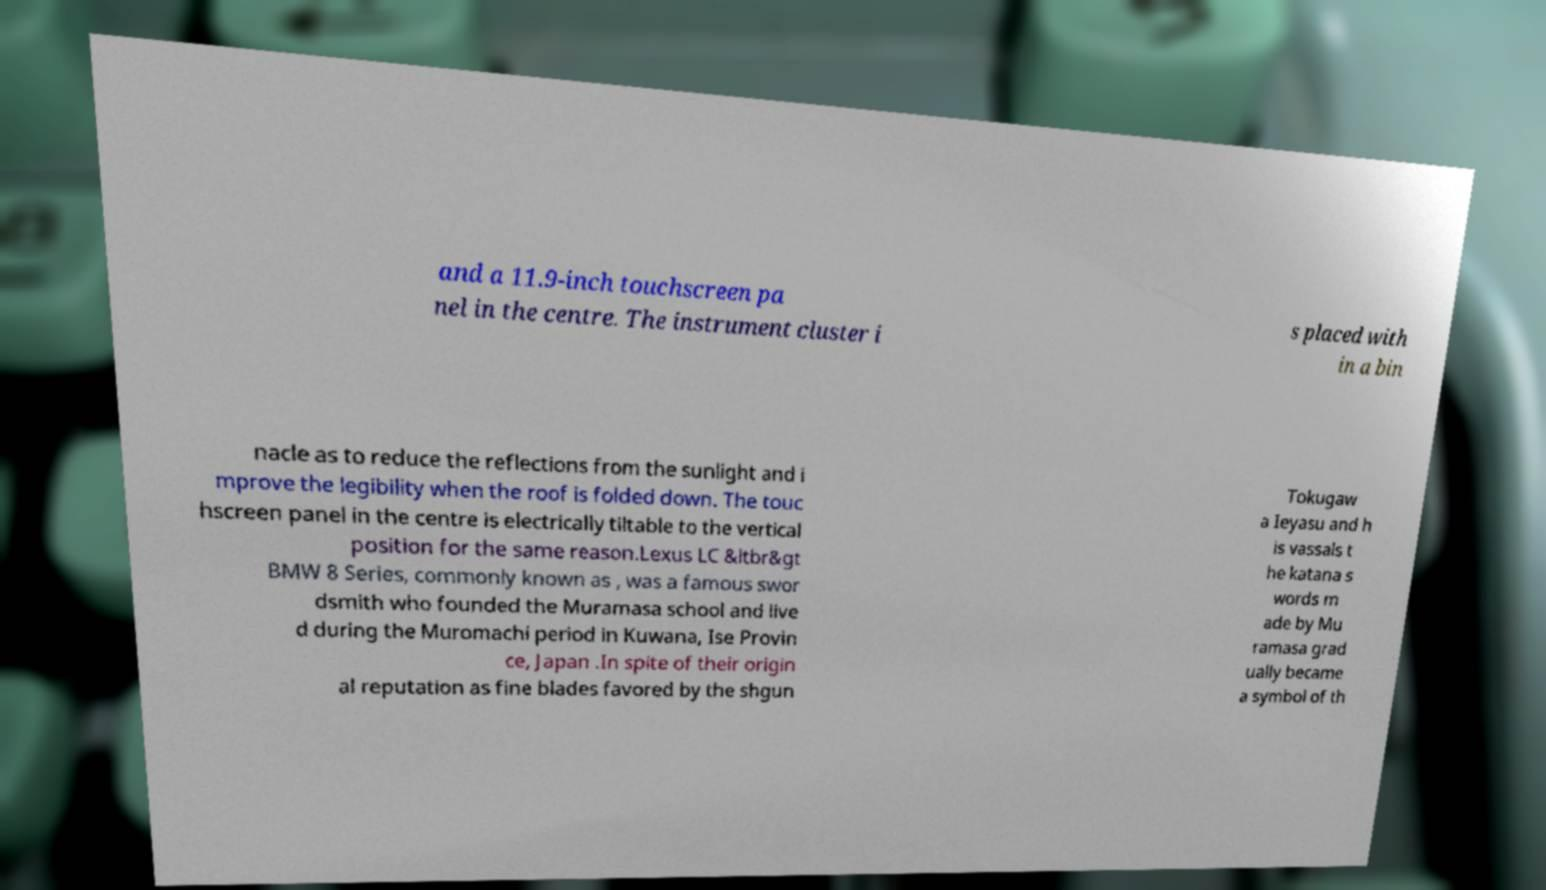Please read and relay the text visible in this image. What does it say? and a 11.9-inch touchscreen pa nel in the centre. The instrument cluster i s placed with in a bin nacle as to reduce the reflections from the sunlight and i mprove the legibility when the roof is folded down. The touc hscreen panel in the centre is electrically tiltable to the vertical position for the same reason.Lexus LC &ltbr&gt BMW 8 Series, commonly known as , was a famous swor dsmith who founded the Muramasa school and live d during the Muromachi period in Kuwana, Ise Provin ce, Japan .In spite of their origin al reputation as fine blades favored by the shgun Tokugaw a Ieyasu and h is vassals t he katana s words m ade by Mu ramasa grad ually became a symbol of th 